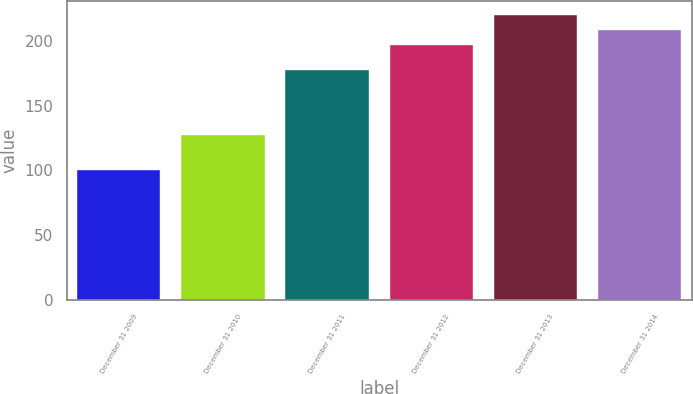<chart> <loc_0><loc_0><loc_500><loc_500><bar_chart><fcel>December 31 2009<fcel>December 31 2010<fcel>December 31 2011<fcel>December 31 2012<fcel>December 31 2013<fcel>December 31 2014<nl><fcel>100<fcel>127.2<fcel>177.8<fcel>196.7<fcel>220.24<fcel>208.9<nl></chart> 